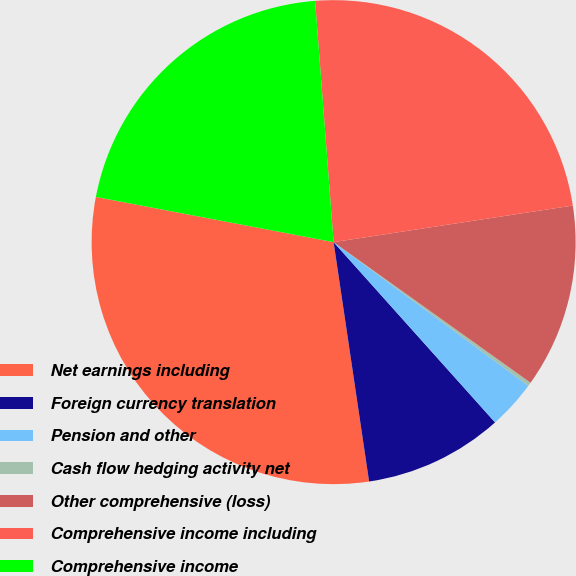Convert chart. <chart><loc_0><loc_0><loc_500><loc_500><pie_chart><fcel>Net earnings including<fcel>Foreign currency translation<fcel>Pension and other<fcel>Cash flow hedging activity net<fcel>Other comprehensive (loss)<fcel>Comprehensive income including<fcel>Comprehensive income<nl><fcel>30.33%<fcel>9.28%<fcel>3.26%<fcel>0.25%<fcel>12.28%<fcel>23.8%<fcel>20.79%<nl></chart> 